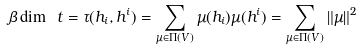Convert formula to latex. <formula><loc_0><loc_0><loc_500><loc_500>\beta \dim \ t = \tau ( h _ { i } , h ^ { i } ) = \sum _ { \mu \in \Pi ( V ) } \mu ( h _ { i } ) \mu ( h ^ { i } ) = \sum _ { \mu \in \Pi ( V ) } \| \mu \| ^ { 2 }</formula> 